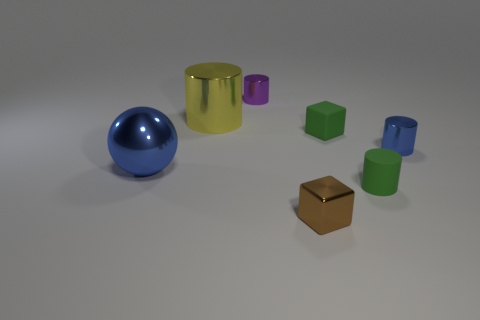Add 2 purple things. How many objects exist? 9 Subtract all balls. How many objects are left? 6 Add 7 purple shiny objects. How many purple shiny objects are left? 8 Add 3 large shiny objects. How many large shiny objects exist? 5 Subtract 1 green cubes. How many objects are left? 6 Subtract all tiny cylinders. Subtract all green matte things. How many objects are left? 2 